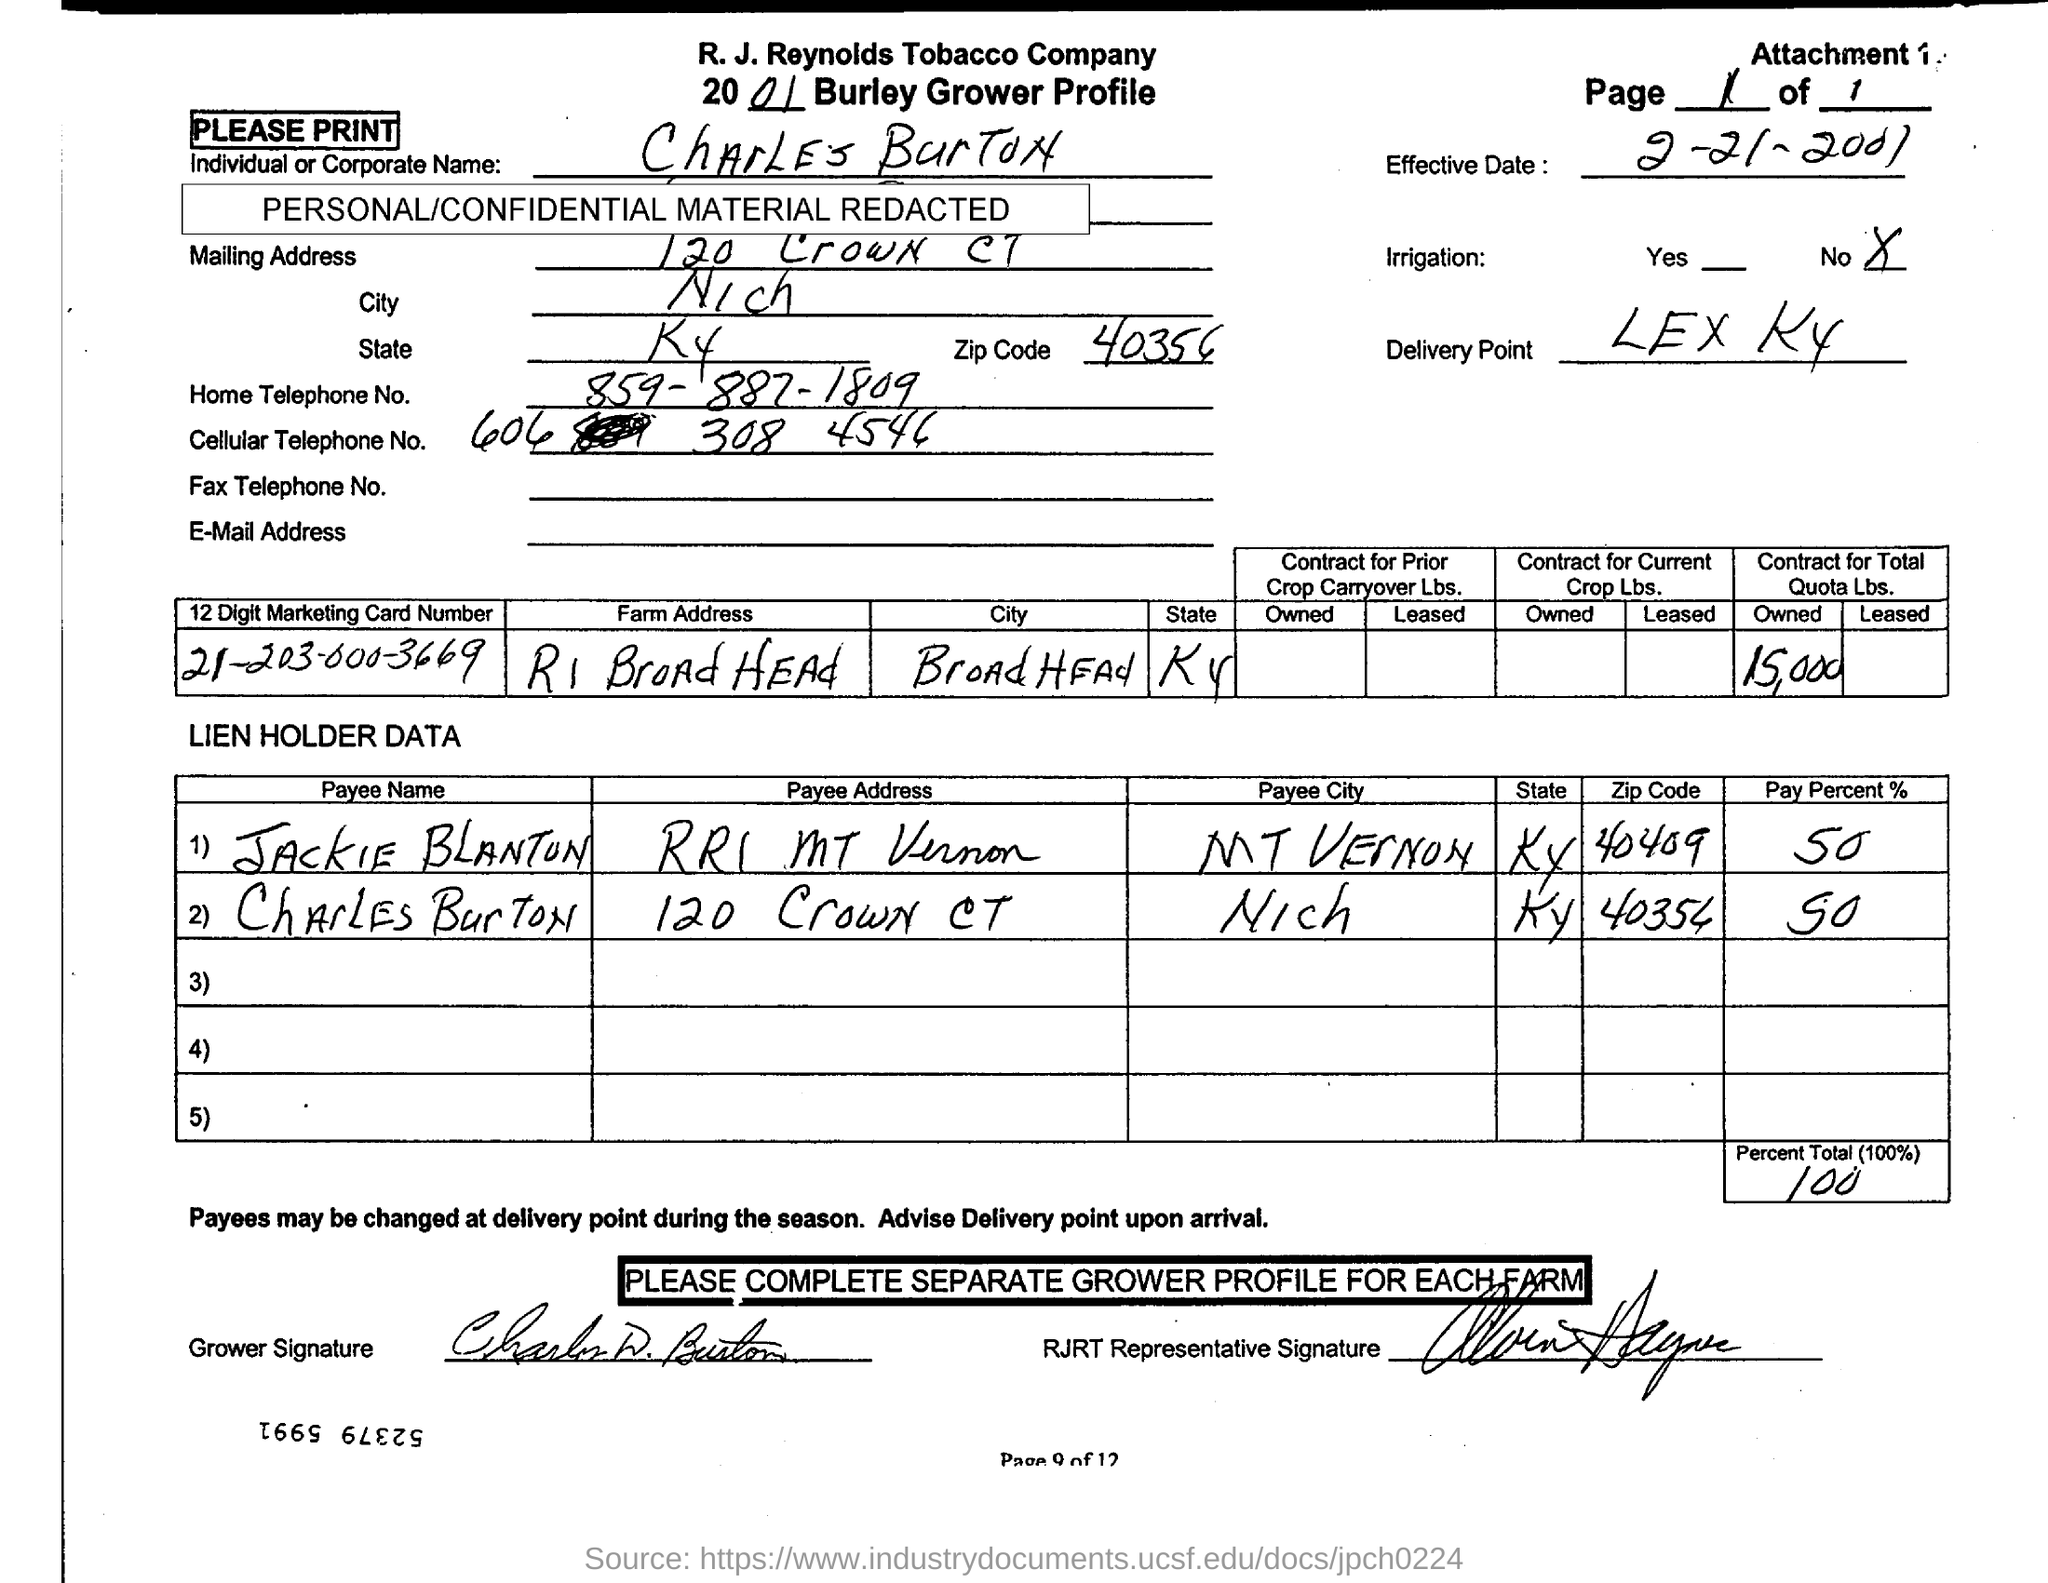Is there any irrigation noted on the contract? According to the document, irrigation is marked as 'No,' indicating that the crop associated with this contract is not irrigated. 